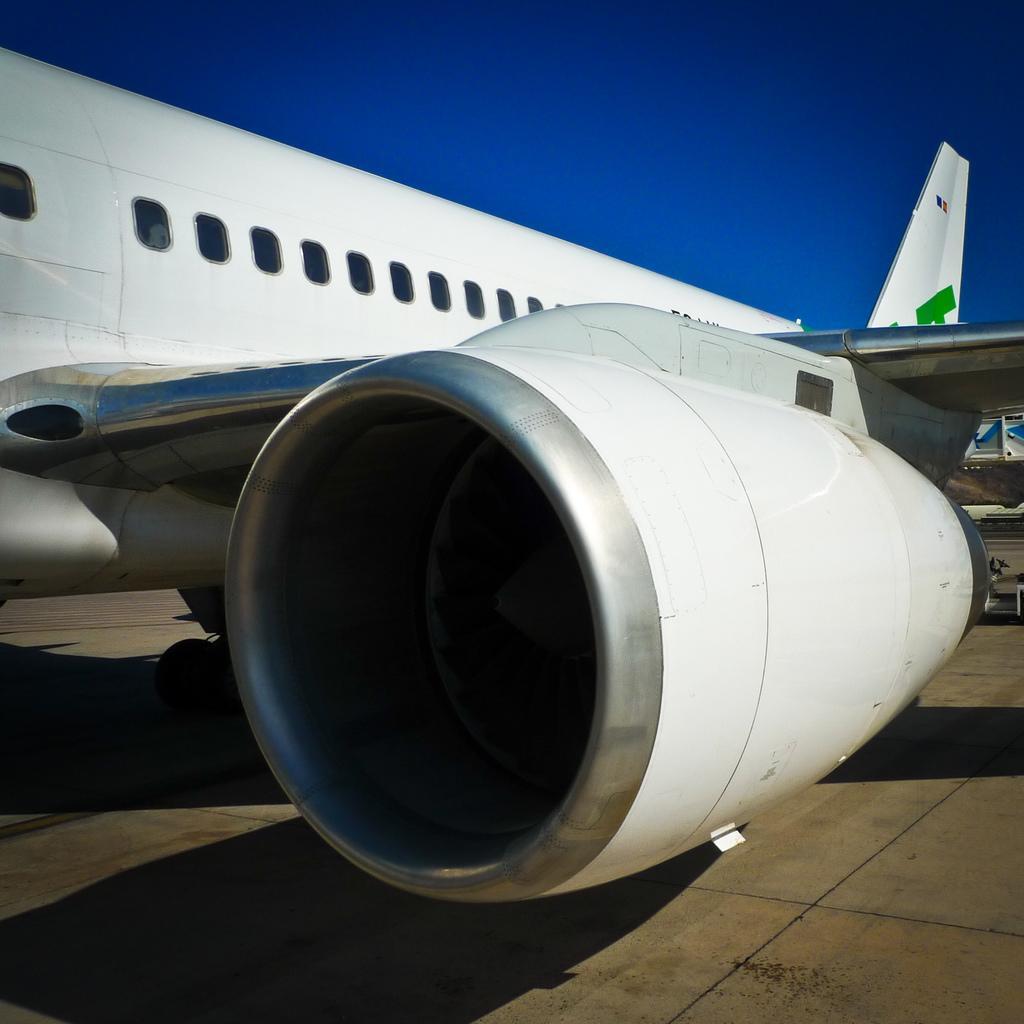Could you give a brief overview of what you see in this image? In this image we can see the propeller of an airplane. At the top there is sky. At the bottom there is floor. 